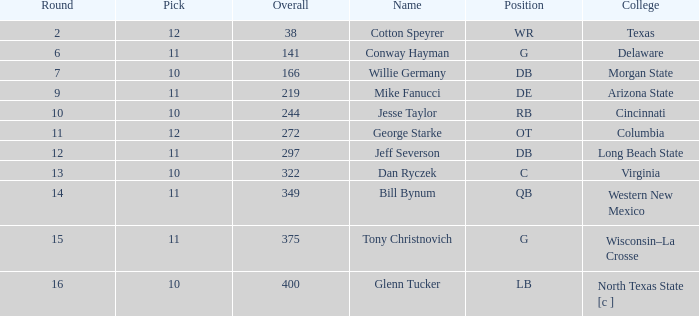What is the smallest round for a cumulative pick of 349 with a pick number in the round greater than 11? None. 